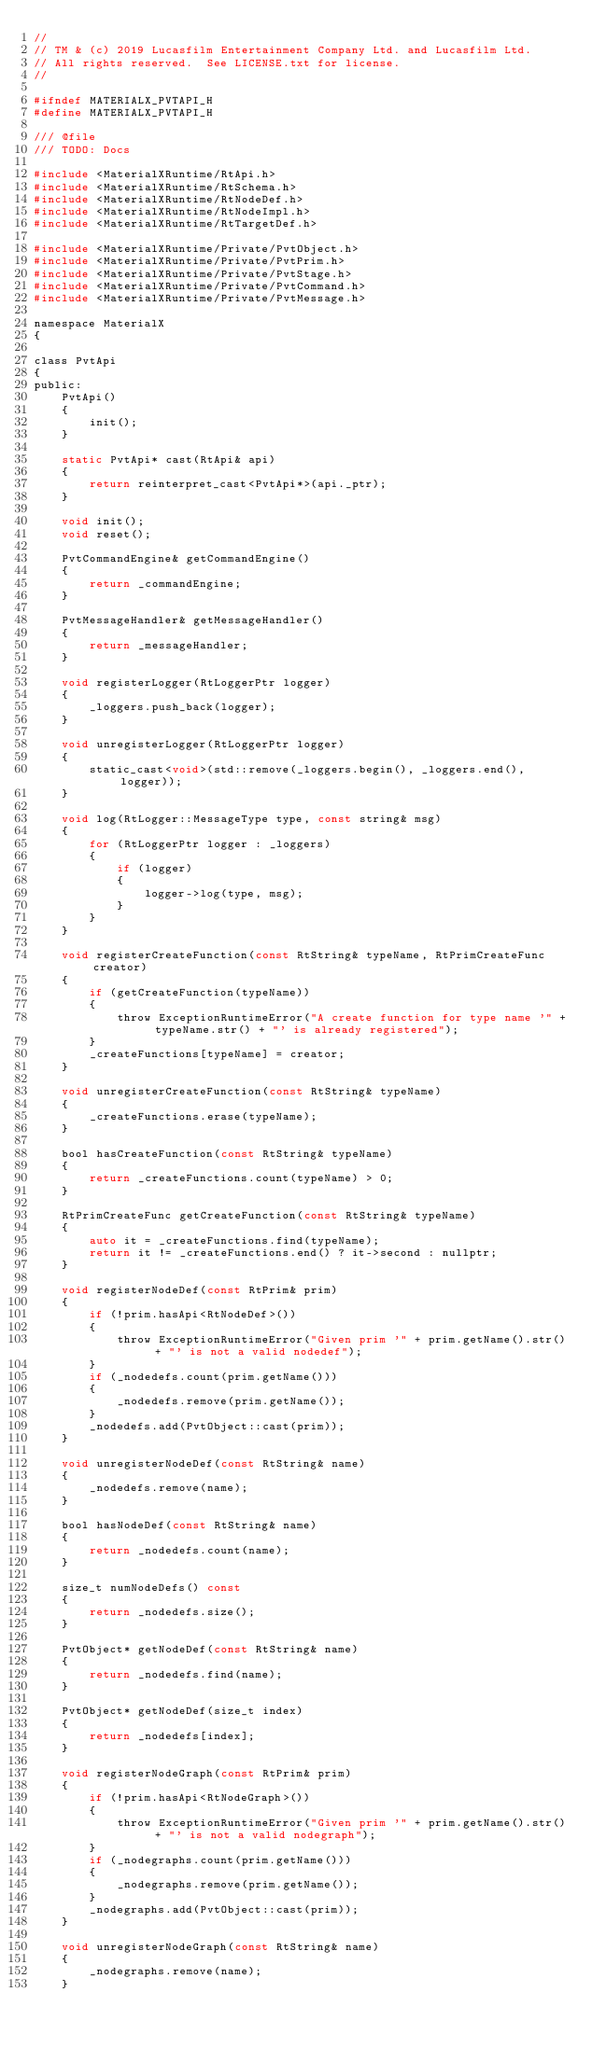<code> <loc_0><loc_0><loc_500><loc_500><_C_>//
// TM & (c) 2019 Lucasfilm Entertainment Company Ltd. and Lucasfilm Ltd.
// All rights reserved.  See LICENSE.txt for license.
//

#ifndef MATERIALX_PVTAPI_H
#define MATERIALX_PVTAPI_H

/// @file
/// TODO: Docs

#include <MaterialXRuntime/RtApi.h>
#include <MaterialXRuntime/RtSchema.h>
#include <MaterialXRuntime/RtNodeDef.h>
#include <MaterialXRuntime/RtNodeImpl.h>
#include <MaterialXRuntime/RtTargetDef.h>

#include <MaterialXRuntime/Private/PvtObject.h>
#include <MaterialXRuntime/Private/PvtPrim.h>
#include <MaterialXRuntime/Private/PvtStage.h>
#include <MaterialXRuntime/Private/PvtCommand.h>
#include <MaterialXRuntime/Private/PvtMessage.h>

namespace MaterialX
{

class PvtApi
{
public:
    PvtApi()
    {
        init();
    }

    static PvtApi* cast(RtApi& api)
    {
        return reinterpret_cast<PvtApi*>(api._ptr);
    }

    void init();
    void reset();

    PvtCommandEngine& getCommandEngine()
    {
        return _commandEngine;
    }

    PvtMessageHandler& getMessageHandler()
    {
        return _messageHandler;
    }

    void registerLogger(RtLoggerPtr logger)
    {
        _loggers.push_back(logger);
    }

    void unregisterLogger(RtLoggerPtr logger)
    {
        static_cast<void>(std::remove(_loggers.begin(), _loggers.end(), logger));
    }

    void log(RtLogger::MessageType type, const string& msg)
    {
        for (RtLoggerPtr logger : _loggers)
        {
            if (logger)
            {
                logger->log(type, msg);
            }
        }
    }

    void registerCreateFunction(const RtString& typeName, RtPrimCreateFunc creator)
    {
        if (getCreateFunction(typeName))
        {
            throw ExceptionRuntimeError("A create function for type name '" + typeName.str() + "' is already registered");
        }
        _createFunctions[typeName] = creator;
    }

    void unregisterCreateFunction(const RtString& typeName)
    {
        _createFunctions.erase(typeName);
    }

    bool hasCreateFunction(const RtString& typeName)
    {
        return _createFunctions.count(typeName) > 0;
    }

    RtPrimCreateFunc getCreateFunction(const RtString& typeName)
    {
        auto it = _createFunctions.find(typeName);
        return it != _createFunctions.end() ? it->second : nullptr;
    }

    void registerNodeDef(const RtPrim& prim)
    {
        if (!prim.hasApi<RtNodeDef>())
        {
            throw ExceptionRuntimeError("Given prim '" + prim.getName().str() + "' is not a valid nodedef");
        }
        if (_nodedefs.count(prim.getName()))
        {
            _nodedefs.remove(prim.getName());
        }
        _nodedefs.add(PvtObject::cast(prim));
    }

    void unregisterNodeDef(const RtString& name)
    {
        _nodedefs.remove(name);
    }

    bool hasNodeDef(const RtString& name)
    {
        return _nodedefs.count(name);
    }

    size_t numNodeDefs() const
    {
        return _nodedefs.size();
    }

    PvtObject* getNodeDef(const RtString& name)
    {
        return _nodedefs.find(name);
    }

    PvtObject* getNodeDef(size_t index)
    {
        return _nodedefs[index];
    }

    void registerNodeGraph(const RtPrim& prim)
    {
        if (!prim.hasApi<RtNodeGraph>())
        {
            throw ExceptionRuntimeError("Given prim '" + prim.getName().str() + "' is not a valid nodegraph");
        }
        if (_nodegraphs.count(prim.getName()))
        {
            _nodegraphs.remove(prim.getName());
        }
        _nodegraphs.add(PvtObject::cast(prim));
    }

    void unregisterNodeGraph(const RtString& name)
    {
        _nodegraphs.remove(name);
    }
</code> 